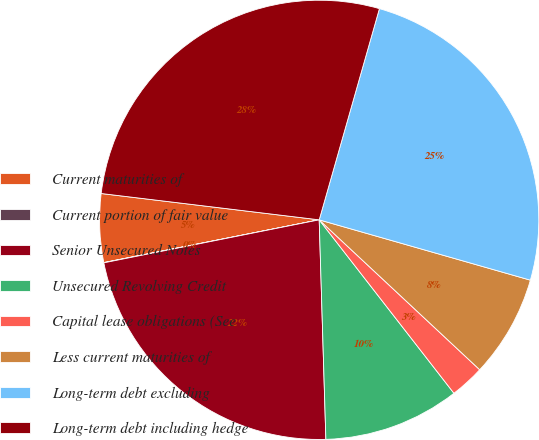Convert chart to OTSL. <chart><loc_0><loc_0><loc_500><loc_500><pie_chart><fcel>Current maturities of<fcel>Current portion of fair value<fcel>Senior Unsecured Notes<fcel>Unsecured Revolving Credit<fcel>Capital lease obligations (See<fcel>Less current maturities of<fcel>Long-term debt excluding<fcel>Long-term debt including hedge<nl><fcel>5.03%<fcel>0.02%<fcel>22.35%<fcel>10.03%<fcel>2.53%<fcel>7.53%<fcel>25.01%<fcel>27.51%<nl></chart> 